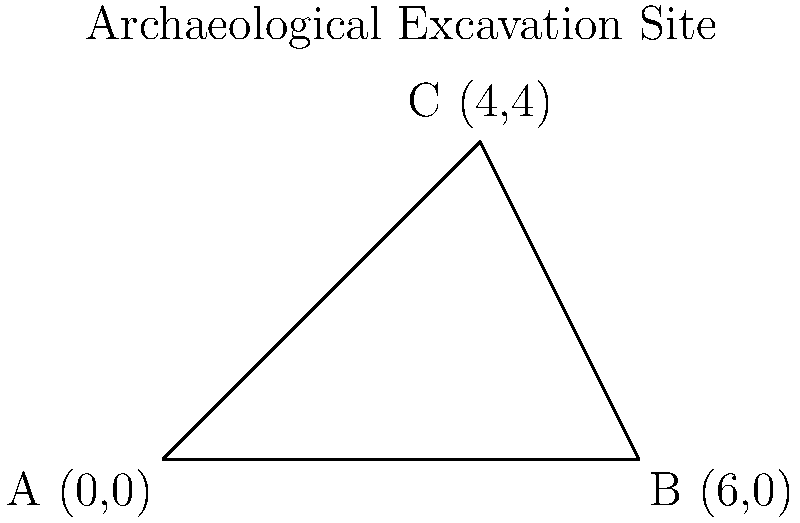An archaeological excavation site has been mapped using a coordinate system. The site forms a triangular shape with vertices at A(0,0), B(6,0), and C(4,4). Calculate the area of this excavation site using coordinate geometry methods. To find the area of the triangular excavation site, we can use the formula for the area of a triangle given the coordinates of its vertices:

Area = $\frac{1}{2}|x_1(y_2 - y_3) + x_2(y_3 - y_1) + x_3(y_1 - y_2)|$

Where $(x_1, y_1)$, $(x_2, y_2)$, and $(x_3, y_3)$ are the coordinates of the three vertices.

Step 1: Identify the coordinates
A: $(x_1, y_1) = (0, 0)$
B: $(x_2, y_2) = (6, 0)$
C: $(x_3, y_3) = (4, 4)$

Step 2: Substitute the values into the formula
Area = $\frac{1}{2}|0(0 - 4) + 6(4 - 0) + 4(0 - 0)|$

Step 3: Simplify
Area = $\frac{1}{2}|0 + 24 + 0|$
Area = $\frac{1}{2}|24|$
Area = $\frac{1}{2} \cdot 24$
Area = 12

Therefore, the area of the archaeological excavation site is 12 square units.
Answer: 12 square units 